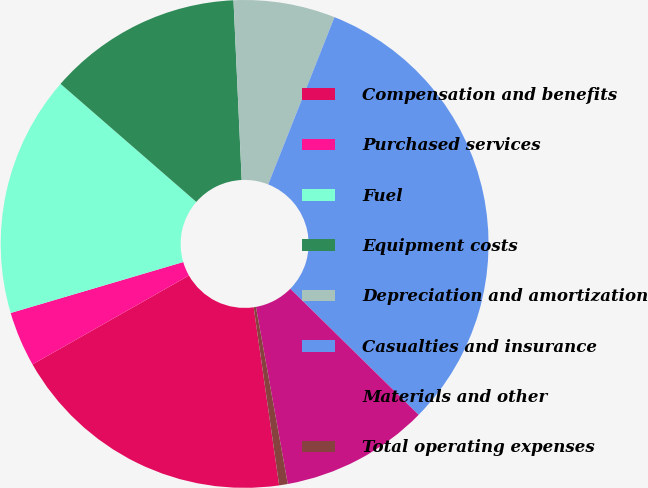Convert chart to OTSL. <chart><loc_0><loc_0><loc_500><loc_500><pie_chart><fcel>Compensation and benefits<fcel>Purchased services<fcel>Fuel<fcel>Equipment costs<fcel>Depreciation and amortization<fcel>Casualties and insurance<fcel>Materials and other<fcel>Total operating expenses<nl><fcel>19.04%<fcel>3.65%<fcel>15.96%<fcel>12.88%<fcel>6.73%<fcel>31.35%<fcel>9.81%<fcel>0.57%<nl></chart> 